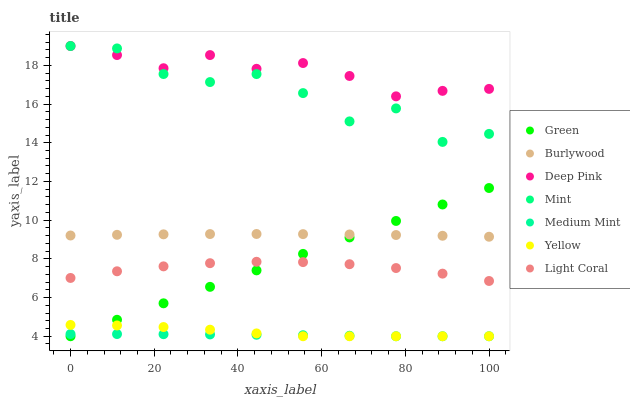Does Medium Mint have the minimum area under the curve?
Answer yes or no. Yes. Does Deep Pink have the maximum area under the curve?
Answer yes or no. Yes. Does Burlywood have the minimum area under the curve?
Answer yes or no. No. Does Burlywood have the maximum area under the curve?
Answer yes or no. No. Is Green the smoothest?
Answer yes or no. Yes. Is Mint the roughest?
Answer yes or no. Yes. Is Deep Pink the smoothest?
Answer yes or no. No. Is Deep Pink the roughest?
Answer yes or no. No. Does Medium Mint have the lowest value?
Answer yes or no. Yes. Does Burlywood have the lowest value?
Answer yes or no. No. Does Mint have the highest value?
Answer yes or no. Yes. Does Burlywood have the highest value?
Answer yes or no. No. Is Light Coral less than Deep Pink?
Answer yes or no. Yes. Is Deep Pink greater than Green?
Answer yes or no. Yes. Does Green intersect Burlywood?
Answer yes or no. Yes. Is Green less than Burlywood?
Answer yes or no. No. Is Green greater than Burlywood?
Answer yes or no. No. Does Light Coral intersect Deep Pink?
Answer yes or no. No. 